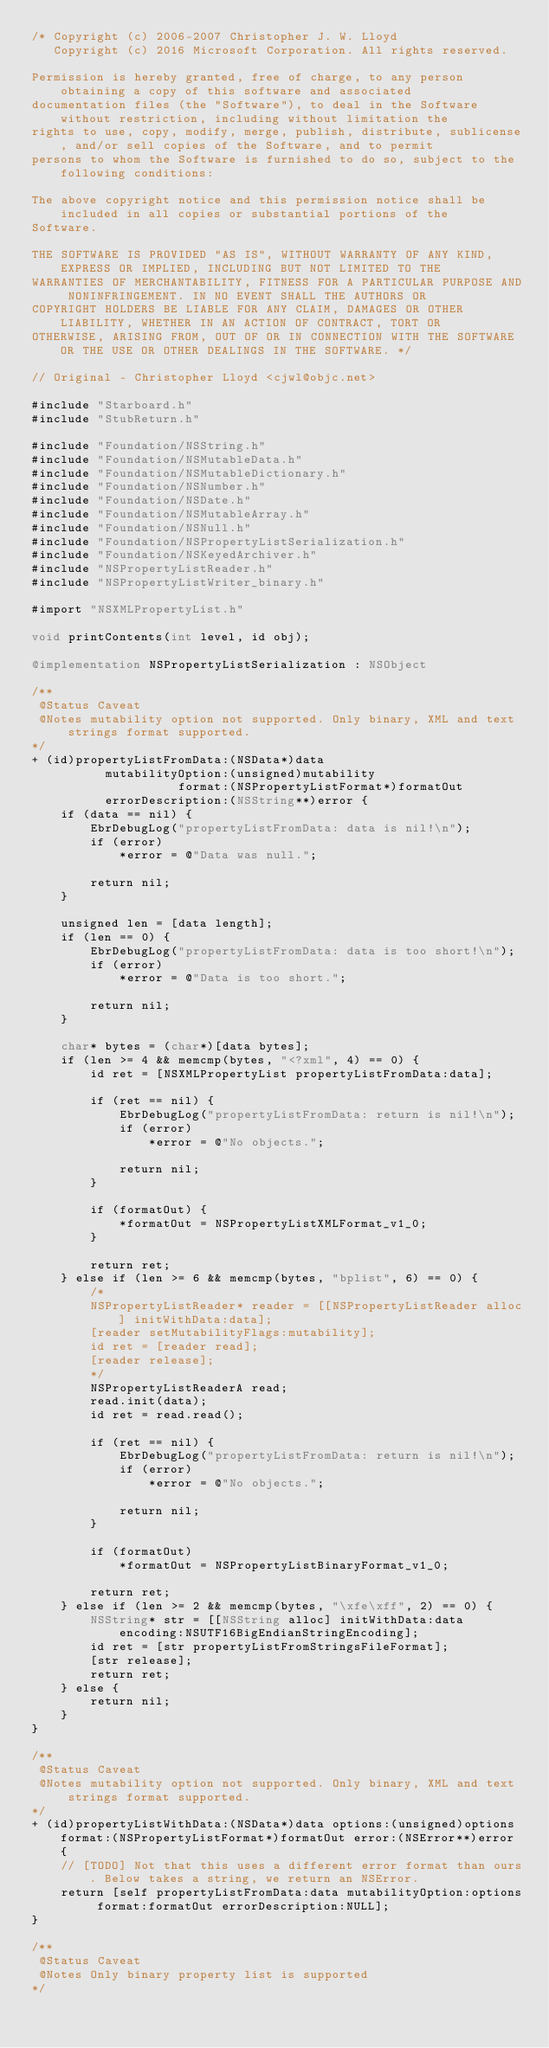<code> <loc_0><loc_0><loc_500><loc_500><_ObjectiveC_>/* Copyright (c) 2006-2007 Christopher J. W. Lloyd
   Copyright (c) 2016 Microsoft Corporation. All rights reserved.

Permission is hereby granted, free of charge, to any person obtaining a copy of this software and associated
documentation files (the "Software"), to deal in the Software without restriction, including without limitation the
rights to use, copy, modify, merge, publish, distribute, sublicense, and/or sell copies of the Software, and to permit
persons to whom the Software is furnished to do so, subject to the following conditions:

The above copyright notice and this permission notice shall be included in all copies or substantial portions of the
Software.

THE SOFTWARE IS PROVIDED "AS IS", WITHOUT WARRANTY OF ANY KIND, EXPRESS OR IMPLIED, INCLUDING BUT NOT LIMITED TO THE
WARRANTIES OF MERCHANTABILITY, FITNESS FOR A PARTICULAR PURPOSE AND NONINFRINGEMENT. IN NO EVENT SHALL THE AUTHORS OR
COPYRIGHT HOLDERS BE LIABLE FOR ANY CLAIM, DAMAGES OR OTHER LIABILITY, WHETHER IN AN ACTION OF CONTRACT, TORT OR
OTHERWISE, ARISING FROM, OUT OF OR IN CONNECTION WITH THE SOFTWARE OR THE USE OR OTHER DEALINGS IN THE SOFTWARE. */

// Original - Christopher Lloyd <cjwl@objc.net>

#include "Starboard.h"
#include "StubReturn.h"

#include "Foundation/NSString.h"
#include "Foundation/NSMutableData.h"
#include "Foundation/NSMutableDictionary.h"
#include "Foundation/NSNumber.h"
#include "Foundation/NSDate.h"
#include "Foundation/NSMutableArray.h"
#include "Foundation/NSNull.h"
#include "Foundation/NSPropertyListSerialization.h"
#include "Foundation/NSKeyedArchiver.h"
#include "NSPropertyListReader.h"
#include "NSPropertyListWriter_binary.h"

#import "NSXMLPropertyList.h"

void printContents(int level, id obj);

@implementation NSPropertyListSerialization : NSObject

/**
 @Status Caveat
 @Notes mutability option not supported. Only binary, XML and text strings format supported.
*/
+ (id)propertyListFromData:(NSData*)data
          mutabilityOption:(unsigned)mutability
                    format:(NSPropertyListFormat*)formatOut
          errorDescription:(NSString**)error {
    if (data == nil) {
        EbrDebugLog("propertyListFromData: data is nil!\n");
        if (error)
            *error = @"Data was null.";

        return nil;
    }

    unsigned len = [data length];
    if (len == 0) {
        EbrDebugLog("propertyListFromData: data is too short!\n");
        if (error)
            *error = @"Data is too short.";

        return nil;
    }

    char* bytes = (char*)[data bytes];
    if (len >= 4 && memcmp(bytes, "<?xml", 4) == 0) {
        id ret = [NSXMLPropertyList propertyListFromData:data];

        if (ret == nil) {
            EbrDebugLog("propertyListFromData: return is nil!\n");
            if (error)
                *error = @"No objects.";

            return nil;
        }

        if (formatOut) {
            *formatOut = NSPropertyListXMLFormat_v1_0;
        }

        return ret;
    } else if (len >= 6 && memcmp(bytes, "bplist", 6) == 0) {
        /*
        NSPropertyListReader* reader = [[NSPropertyListReader alloc] initWithData:data];
        [reader setMutabilityFlags:mutability];
        id ret = [reader read];
        [reader release];
        */
        NSPropertyListReaderA read;
        read.init(data);
        id ret = read.read();

        if (ret == nil) {
            EbrDebugLog("propertyListFromData: return is nil!\n");
            if (error)
                *error = @"No objects.";

            return nil;
        }

        if (formatOut)
            *formatOut = NSPropertyListBinaryFormat_v1_0;

        return ret;
    } else if (len >= 2 && memcmp(bytes, "\xfe\xff", 2) == 0) {
        NSString* str = [[NSString alloc] initWithData:data encoding:NSUTF16BigEndianStringEncoding];
        id ret = [str propertyListFromStringsFileFormat];
        [str release];
        return ret;
    } else {
        return nil;
    }
}

/**
 @Status Caveat
 @Notes mutability option not supported. Only binary, XML and text strings format supported.
*/
+ (id)propertyListWithData:(NSData*)data options:(unsigned)options format:(NSPropertyListFormat*)formatOut error:(NSError**)error {
    // [TODO] Not that this uses a different error format than ours. Below takes a string, we return an NSError.
    return [self propertyListFromData:data mutabilityOption:options format:formatOut errorDescription:NULL];
}

/**
 @Status Caveat
 @Notes Only binary property list is supported
*/</code> 